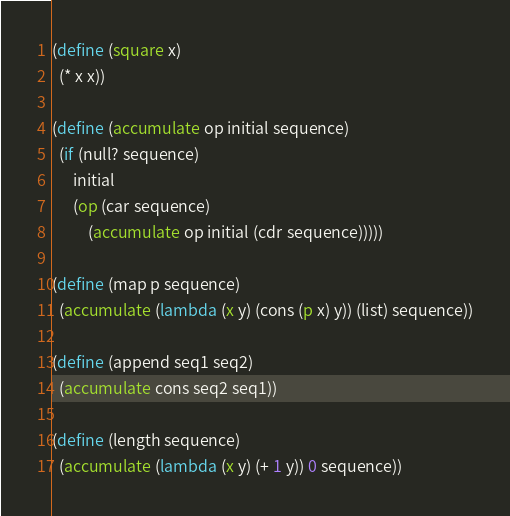Convert code to text. <code><loc_0><loc_0><loc_500><loc_500><_Scheme_>(define (square x)
  (* x x))

(define (accumulate op initial sequence)
  (if (null? sequence)
      initial
      (op (car sequence)
          (accumulate op initial (cdr sequence)))))

(define (map p sequence)
  (accumulate (lambda (x y) (cons (p x) y)) (list) sequence))

(define (append seq1 seq2)
  (accumulate cons seq2 seq1))

(define (length sequence)
  (accumulate (lambda (x y) (+ 1 y)) 0 sequence))
</code> 